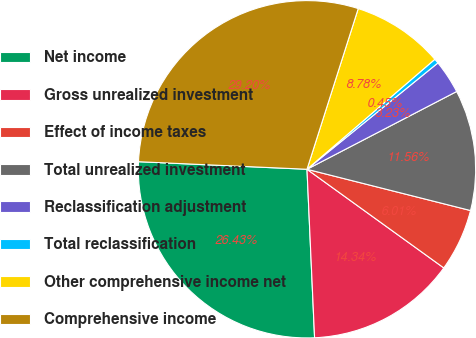Convert chart to OTSL. <chart><loc_0><loc_0><loc_500><loc_500><pie_chart><fcel>Net income<fcel>Gross unrealized investment<fcel>Effect of income taxes<fcel>Total unrealized investment<fcel>Reclassification adjustment<fcel>Total reclassification<fcel>Other comprehensive income net<fcel>Comprehensive income<nl><fcel>26.43%<fcel>14.34%<fcel>6.01%<fcel>11.56%<fcel>3.23%<fcel>0.45%<fcel>8.78%<fcel>29.2%<nl></chart> 